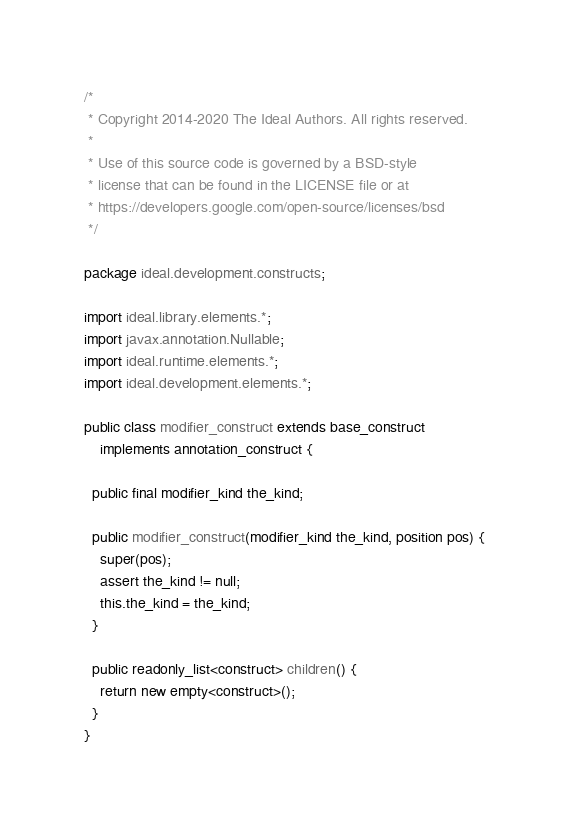Convert code to text. <code><loc_0><loc_0><loc_500><loc_500><_Java_>/*
 * Copyright 2014-2020 The Ideal Authors. All rights reserved.
 *
 * Use of this source code is governed by a BSD-style
 * license that can be found in the LICENSE file or at
 * https://developers.google.com/open-source/licenses/bsd
 */

package ideal.development.constructs;

import ideal.library.elements.*;
import javax.annotation.Nullable;
import ideal.runtime.elements.*;
import ideal.development.elements.*;

public class modifier_construct extends base_construct
    implements annotation_construct {

  public final modifier_kind the_kind;

  public modifier_construct(modifier_kind the_kind, position pos) {
    super(pos);
    assert the_kind != null;
    this.the_kind = the_kind;
  }

  public readonly_list<construct> children() {
    return new empty<construct>();
  }
}
</code> 